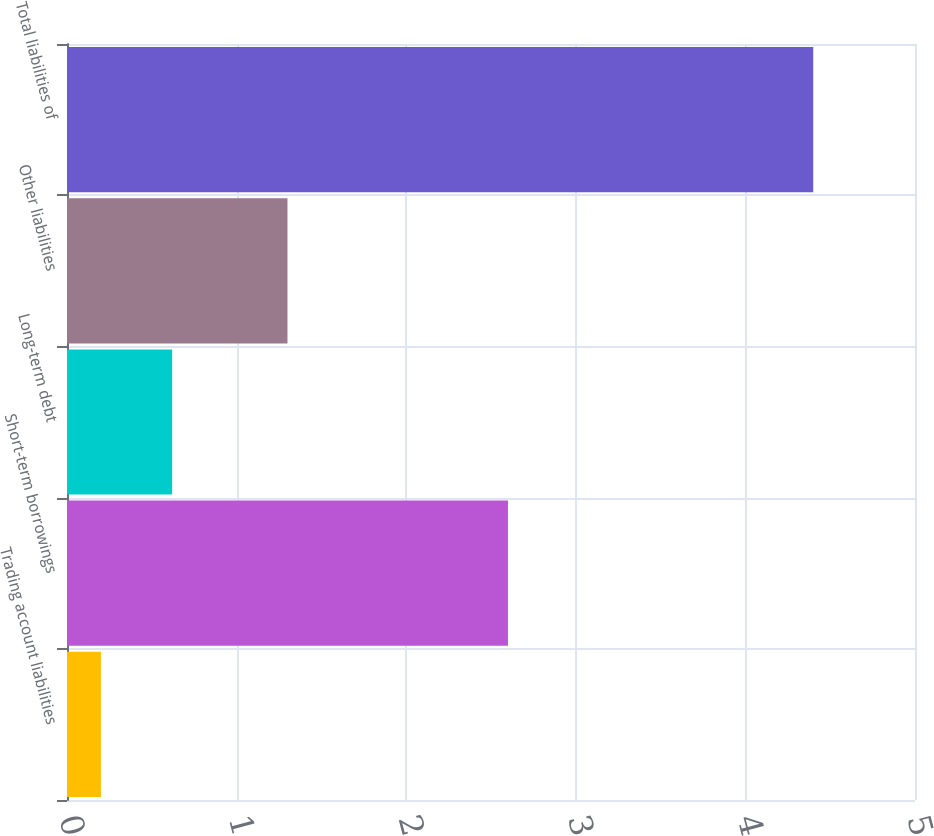<chart> <loc_0><loc_0><loc_500><loc_500><bar_chart><fcel>Trading account liabilities<fcel>Short-term borrowings<fcel>Long-term debt<fcel>Other liabilities<fcel>Total liabilities of<nl><fcel>0.2<fcel>2.6<fcel>0.62<fcel>1.3<fcel>4.4<nl></chart> 